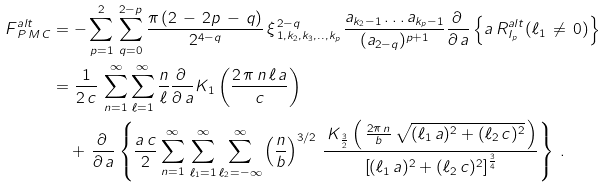Convert formula to latex. <formula><loc_0><loc_0><loc_500><loc_500>F _ { \, P \, M \, C } ^ { a l t } & = - \sum _ { p = 1 } ^ { 2 } \, \sum _ { q = 0 } ^ { 2 - p } \frac { \pi \, ( 2 \, - \, 2 p \, - \, q ) } { 2 ^ { 4 - q } } \, \xi ^ { \, 2 - q } _ { \, 1 , k _ { 2 } , k _ { 3 } , . . , k _ { p } } \, \frac { a _ { k _ { 2 } - 1 } \dots a _ { k _ { p } - 1 } } { ( a _ { 2 - q } ) ^ { p + 1 } } \frac { \partial \, } { \partial \, a } \left \{ a \, R _ { I _ { p } } ^ { a l t } ( \ell _ { 1 } \, \ne \, 0 ) \right \} \\ & = \frac { 1 } { 2 \, c } \, \sum _ { n = 1 } ^ { \infty } \sum _ { \ell = 1 } ^ { \infty } \frac { n } { \ell } \frac { \partial \, } { \partial \, a } K _ { 1 } \left ( \frac { 2 \, \pi \, n \, \ell \, a } { c } \right ) \\ & \quad + \, \frac { \partial \, } { \partial \, a } \left \{ \frac { a \, c } { 2 } \sum _ { n = 1 } ^ { \infty } \, \sum _ { \ell _ { 1 } = 1 } ^ { \infty } \sum _ { \substack { \ell _ { 2 } = - \infty \\ } } ^ { \infty } \left ( \frac { n } { b } \right ) ^ { 3 / 2 } \, \frac { \, K _ { \frac { 3 } { 2 } } \left ( \, \frac { 2 \pi \, n } { b } \, \sqrt { ( \ell _ { 1 } \, a ) ^ { 2 } + ( \ell _ { 2 } \, c ) ^ { 2 } } \, \right ) } { \left [ ( \ell _ { 1 } \, a ) ^ { 2 } + ( \ell _ { 2 } \, c ) ^ { 2 } \right ] ^ { \frac { 3 } { 4 } } } \right \} \, .</formula> 